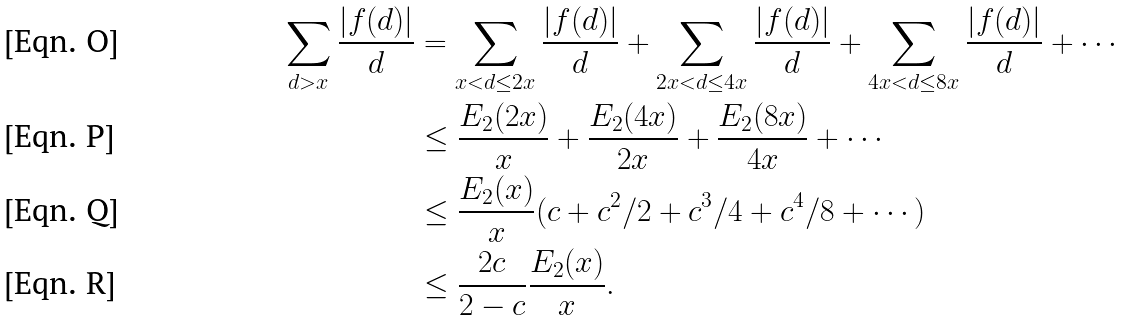Convert formula to latex. <formula><loc_0><loc_0><loc_500><loc_500>\sum _ { d > x } \frac { | f ( d ) | } { d } & = \sum _ { x < d \leq 2 x } \frac { | f ( d ) | } { d } + \sum _ { 2 x < d \leq 4 x } \frac { | f ( d ) | } { d } + \sum _ { 4 x < d \leq 8 x } \frac { | f ( d ) | } { d } + \cdots \\ & \leq \frac { E _ { 2 } ( 2 x ) } { x } + \frac { E _ { 2 } ( 4 x ) } { 2 x } + \frac { E _ { 2 } ( 8 x ) } { 4 x } + \cdots \\ & \leq \frac { E _ { 2 } ( x ) } { x } ( c + c ^ { 2 } / 2 + c ^ { 3 } / 4 + c ^ { 4 } / 8 + \cdots ) \\ & \leq \frac { 2 c } { 2 - c } \frac { E _ { 2 } ( x ) } { x } .</formula> 